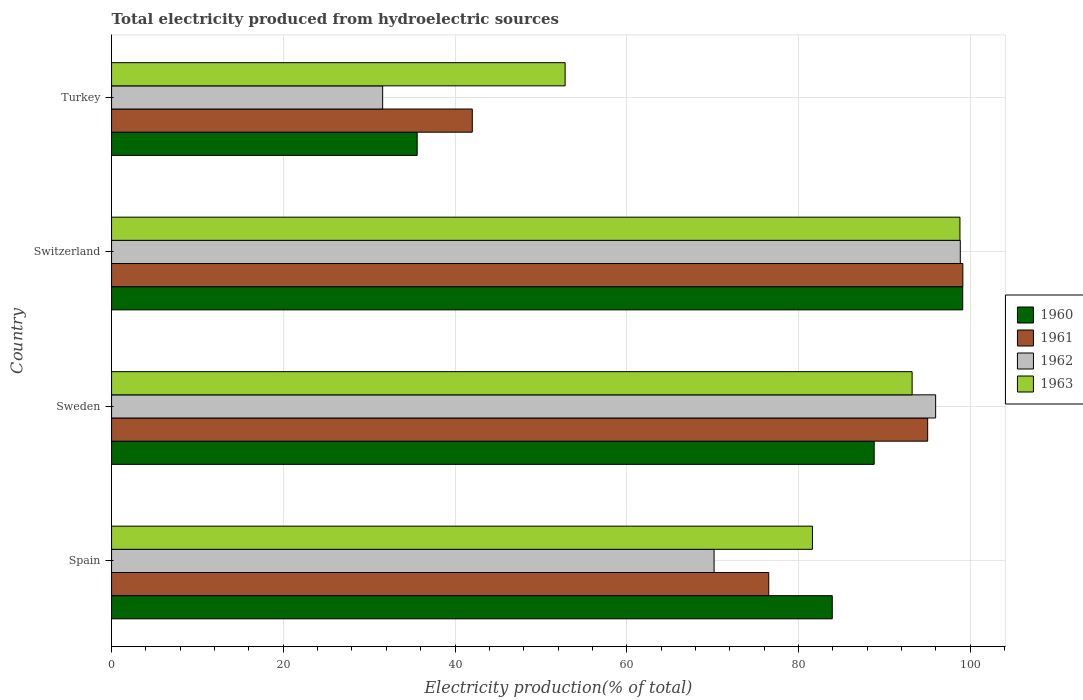How many bars are there on the 4th tick from the top?
Make the answer very short. 4. What is the total electricity produced in 1961 in Spain?
Keep it short and to the point. 76.54. Across all countries, what is the maximum total electricity produced in 1963?
Provide a succinct answer. 98.81. Across all countries, what is the minimum total electricity produced in 1961?
Offer a very short reply. 42.01. In which country was the total electricity produced in 1963 maximum?
Provide a succinct answer. Switzerland. In which country was the total electricity produced in 1961 minimum?
Offer a terse response. Turkey. What is the total total electricity produced in 1962 in the graph?
Give a very brief answer. 296.57. What is the difference between the total electricity produced in 1961 in Spain and that in Switzerland?
Provide a succinct answer. -22.61. What is the difference between the total electricity produced in 1960 in Switzerland and the total electricity produced in 1963 in Turkey?
Keep it short and to the point. 46.31. What is the average total electricity produced in 1960 per country?
Your response must be concise. 76.87. What is the difference between the total electricity produced in 1960 and total electricity produced in 1961 in Switzerland?
Keep it short and to the point. -0.02. In how many countries, is the total electricity produced in 1962 greater than 72 %?
Your response must be concise. 2. What is the ratio of the total electricity produced in 1963 in Spain to that in Switzerland?
Offer a very short reply. 0.83. What is the difference between the highest and the second highest total electricity produced in 1960?
Make the answer very short. 10.31. What is the difference between the highest and the lowest total electricity produced in 1960?
Make the answer very short. 63.54. Is the sum of the total electricity produced in 1961 in Spain and Switzerland greater than the maximum total electricity produced in 1962 across all countries?
Your answer should be very brief. Yes. What does the 1st bar from the top in Spain represents?
Give a very brief answer. 1963. What does the 2nd bar from the bottom in Switzerland represents?
Provide a succinct answer. 1961. Is it the case that in every country, the sum of the total electricity produced in 1962 and total electricity produced in 1961 is greater than the total electricity produced in 1963?
Ensure brevity in your answer.  Yes. Are all the bars in the graph horizontal?
Your response must be concise. Yes. How many countries are there in the graph?
Your response must be concise. 4. Are the values on the major ticks of X-axis written in scientific E-notation?
Your answer should be compact. No. Does the graph contain grids?
Offer a terse response. Yes. Where does the legend appear in the graph?
Offer a terse response. Center right. What is the title of the graph?
Offer a very short reply. Total electricity produced from hydroelectric sources. What is the label or title of the Y-axis?
Make the answer very short. Country. What is the Electricity production(% of total) of 1960 in Spain?
Provide a succinct answer. 83.94. What is the Electricity production(% of total) of 1961 in Spain?
Provide a succinct answer. 76.54. What is the Electricity production(% of total) of 1962 in Spain?
Keep it short and to the point. 70.17. What is the Electricity production(% of total) of 1963 in Spain?
Offer a terse response. 81.63. What is the Electricity production(% of total) in 1960 in Sweden?
Offer a terse response. 88.82. What is the Electricity production(% of total) in 1961 in Sweden?
Make the answer very short. 95.05. What is the Electricity production(% of total) of 1962 in Sweden?
Provide a succinct answer. 95.98. What is the Electricity production(% of total) in 1963 in Sweden?
Offer a very short reply. 93.24. What is the Electricity production(% of total) in 1960 in Switzerland?
Your answer should be very brief. 99.13. What is the Electricity production(% of total) in 1961 in Switzerland?
Give a very brief answer. 99.15. What is the Electricity production(% of total) of 1962 in Switzerland?
Make the answer very short. 98.85. What is the Electricity production(% of total) of 1963 in Switzerland?
Give a very brief answer. 98.81. What is the Electricity production(% of total) in 1960 in Turkey?
Make the answer very short. 35.6. What is the Electricity production(% of total) in 1961 in Turkey?
Make the answer very short. 42.01. What is the Electricity production(% of total) in 1962 in Turkey?
Your answer should be very brief. 31.57. What is the Electricity production(% of total) in 1963 in Turkey?
Provide a short and direct response. 52.82. Across all countries, what is the maximum Electricity production(% of total) in 1960?
Offer a very short reply. 99.13. Across all countries, what is the maximum Electricity production(% of total) in 1961?
Give a very brief answer. 99.15. Across all countries, what is the maximum Electricity production(% of total) of 1962?
Give a very brief answer. 98.85. Across all countries, what is the maximum Electricity production(% of total) of 1963?
Ensure brevity in your answer.  98.81. Across all countries, what is the minimum Electricity production(% of total) in 1960?
Provide a succinct answer. 35.6. Across all countries, what is the minimum Electricity production(% of total) of 1961?
Provide a short and direct response. 42.01. Across all countries, what is the minimum Electricity production(% of total) of 1962?
Offer a terse response. 31.57. Across all countries, what is the minimum Electricity production(% of total) in 1963?
Your answer should be compact. 52.82. What is the total Electricity production(% of total) of 1960 in the graph?
Provide a succinct answer. 307.48. What is the total Electricity production(% of total) in 1961 in the graph?
Your answer should be very brief. 312.75. What is the total Electricity production(% of total) of 1962 in the graph?
Offer a terse response. 296.57. What is the total Electricity production(% of total) in 1963 in the graph?
Offer a very short reply. 326.5. What is the difference between the Electricity production(% of total) of 1960 in Spain and that in Sweden?
Your answer should be compact. -4.88. What is the difference between the Electricity production(% of total) of 1961 in Spain and that in Sweden?
Your answer should be compact. -18.51. What is the difference between the Electricity production(% of total) of 1962 in Spain and that in Sweden?
Make the answer very short. -25.8. What is the difference between the Electricity production(% of total) of 1963 in Spain and that in Sweden?
Provide a succinct answer. -11.61. What is the difference between the Electricity production(% of total) of 1960 in Spain and that in Switzerland?
Provide a succinct answer. -15.19. What is the difference between the Electricity production(% of total) of 1961 in Spain and that in Switzerland?
Your answer should be very brief. -22.61. What is the difference between the Electricity production(% of total) in 1962 in Spain and that in Switzerland?
Provide a succinct answer. -28.67. What is the difference between the Electricity production(% of total) of 1963 in Spain and that in Switzerland?
Offer a very short reply. -17.18. What is the difference between the Electricity production(% of total) of 1960 in Spain and that in Turkey?
Your answer should be compact. 48.34. What is the difference between the Electricity production(% of total) of 1961 in Spain and that in Turkey?
Provide a succinct answer. 34.53. What is the difference between the Electricity production(% of total) in 1962 in Spain and that in Turkey?
Your answer should be compact. 38.6. What is the difference between the Electricity production(% of total) in 1963 in Spain and that in Turkey?
Your response must be concise. 28.8. What is the difference between the Electricity production(% of total) in 1960 in Sweden and that in Switzerland?
Keep it short and to the point. -10.31. What is the difference between the Electricity production(% of total) in 1961 in Sweden and that in Switzerland?
Your answer should be compact. -4.1. What is the difference between the Electricity production(% of total) of 1962 in Sweden and that in Switzerland?
Your response must be concise. -2.87. What is the difference between the Electricity production(% of total) in 1963 in Sweden and that in Switzerland?
Offer a terse response. -5.57. What is the difference between the Electricity production(% of total) of 1960 in Sweden and that in Turkey?
Make the answer very short. 53.22. What is the difference between the Electricity production(% of total) in 1961 in Sweden and that in Turkey?
Your answer should be compact. 53.04. What is the difference between the Electricity production(% of total) in 1962 in Sweden and that in Turkey?
Ensure brevity in your answer.  64.4. What is the difference between the Electricity production(% of total) in 1963 in Sweden and that in Turkey?
Your response must be concise. 40.41. What is the difference between the Electricity production(% of total) in 1960 in Switzerland and that in Turkey?
Your answer should be very brief. 63.54. What is the difference between the Electricity production(% of total) in 1961 in Switzerland and that in Turkey?
Keep it short and to the point. 57.13. What is the difference between the Electricity production(% of total) in 1962 in Switzerland and that in Turkey?
Your answer should be very brief. 67.27. What is the difference between the Electricity production(% of total) of 1963 in Switzerland and that in Turkey?
Your answer should be compact. 45.98. What is the difference between the Electricity production(% of total) in 1960 in Spain and the Electricity production(% of total) in 1961 in Sweden?
Offer a very short reply. -11.11. What is the difference between the Electricity production(% of total) in 1960 in Spain and the Electricity production(% of total) in 1962 in Sweden?
Provide a succinct answer. -12.04. What is the difference between the Electricity production(% of total) in 1960 in Spain and the Electricity production(% of total) in 1963 in Sweden?
Offer a terse response. -9.3. What is the difference between the Electricity production(% of total) of 1961 in Spain and the Electricity production(% of total) of 1962 in Sweden?
Offer a terse response. -19.44. What is the difference between the Electricity production(% of total) in 1961 in Spain and the Electricity production(% of total) in 1963 in Sweden?
Offer a very short reply. -16.7. What is the difference between the Electricity production(% of total) of 1962 in Spain and the Electricity production(% of total) of 1963 in Sweden?
Offer a very short reply. -23.06. What is the difference between the Electricity production(% of total) in 1960 in Spain and the Electricity production(% of total) in 1961 in Switzerland?
Your response must be concise. -15.21. What is the difference between the Electricity production(% of total) of 1960 in Spain and the Electricity production(% of total) of 1962 in Switzerland?
Provide a short and direct response. -14.91. What is the difference between the Electricity production(% of total) in 1960 in Spain and the Electricity production(% of total) in 1963 in Switzerland?
Give a very brief answer. -14.87. What is the difference between the Electricity production(% of total) of 1961 in Spain and the Electricity production(% of total) of 1962 in Switzerland?
Offer a terse response. -22.31. What is the difference between the Electricity production(% of total) of 1961 in Spain and the Electricity production(% of total) of 1963 in Switzerland?
Your response must be concise. -22.27. What is the difference between the Electricity production(% of total) of 1962 in Spain and the Electricity production(% of total) of 1963 in Switzerland?
Your answer should be very brief. -28.63. What is the difference between the Electricity production(% of total) in 1960 in Spain and the Electricity production(% of total) in 1961 in Turkey?
Provide a short and direct response. 41.92. What is the difference between the Electricity production(% of total) of 1960 in Spain and the Electricity production(% of total) of 1962 in Turkey?
Offer a terse response. 52.36. What is the difference between the Electricity production(% of total) of 1960 in Spain and the Electricity production(% of total) of 1963 in Turkey?
Ensure brevity in your answer.  31.11. What is the difference between the Electricity production(% of total) of 1961 in Spain and the Electricity production(% of total) of 1962 in Turkey?
Offer a very short reply. 44.97. What is the difference between the Electricity production(% of total) in 1961 in Spain and the Electricity production(% of total) in 1963 in Turkey?
Make the answer very short. 23.72. What is the difference between the Electricity production(% of total) in 1962 in Spain and the Electricity production(% of total) in 1963 in Turkey?
Your response must be concise. 17.35. What is the difference between the Electricity production(% of total) in 1960 in Sweden and the Electricity production(% of total) in 1961 in Switzerland?
Ensure brevity in your answer.  -10.33. What is the difference between the Electricity production(% of total) in 1960 in Sweden and the Electricity production(% of total) in 1962 in Switzerland?
Your answer should be compact. -10.03. What is the difference between the Electricity production(% of total) of 1960 in Sweden and the Electricity production(% of total) of 1963 in Switzerland?
Your answer should be very brief. -9.99. What is the difference between the Electricity production(% of total) in 1961 in Sweden and the Electricity production(% of total) in 1962 in Switzerland?
Provide a short and direct response. -3.8. What is the difference between the Electricity production(% of total) of 1961 in Sweden and the Electricity production(% of total) of 1963 in Switzerland?
Make the answer very short. -3.76. What is the difference between the Electricity production(% of total) of 1962 in Sweden and the Electricity production(% of total) of 1963 in Switzerland?
Provide a succinct answer. -2.83. What is the difference between the Electricity production(% of total) of 1960 in Sweden and the Electricity production(% of total) of 1961 in Turkey?
Your response must be concise. 46.81. What is the difference between the Electricity production(% of total) in 1960 in Sweden and the Electricity production(% of total) in 1962 in Turkey?
Make the answer very short. 57.25. What is the difference between the Electricity production(% of total) in 1960 in Sweden and the Electricity production(% of total) in 1963 in Turkey?
Ensure brevity in your answer.  36. What is the difference between the Electricity production(% of total) in 1961 in Sweden and the Electricity production(% of total) in 1962 in Turkey?
Your response must be concise. 63.48. What is the difference between the Electricity production(% of total) in 1961 in Sweden and the Electricity production(% of total) in 1963 in Turkey?
Ensure brevity in your answer.  42.22. What is the difference between the Electricity production(% of total) in 1962 in Sweden and the Electricity production(% of total) in 1963 in Turkey?
Your response must be concise. 43.15. What is the difference between the Electricity production(% of total) in 1960 in Switzerland and the Electricity production(% of total) in 1961 in Turkey?
Ensure brevity in your answer.  57.12. What is the difference between the Electricity production(% of total) of 1960 in Switzerland and the Electricity production(% of total) of 1962 in Turkey?
Provide a short and direct response. 67.56. What is the difference between the Electricity production(% of total) of 1960 in Switzerland and the Electricity production(% of total) of 1963 in Turkey?
Ensure brevity in your answer.  46.31. What is the difference between the Electricity production(% of total) of 1961 in Switzerland and the Electricity production(% of total) of 1962 in Turkey?
Make the answer very short. 67.57. What is the difference between the Electricity production(% of total) of 1961 in Switzerland and the Electricity production(% of total) of 1963 in Turkey?
Keep it short and to the point. 46.32. What is the difference between the Electricity production(% of total) in 1962 in Switzerland and the Electricity production(% of total) in 1963 in Turkey?
Your answer should be very brief. 46.02. What is the average Electricity production(% of total) of 1960 per country?
Your answer should be compact. 76.87. What is the average Electricity production(% of total) in 1961 per country?
Your response must be concise. 78.19. What is the average Electricity production(% of total) in 1962 per country?
Give a very brief answer. 74.14. What is the average Electricity production(% of total) of 1963 per country?
Keep it short and to the point. 81.62. What is the difference between the Electricity production(% of total) in 1960 and Electricity production(% of total) in 1961 in Spain?
Offer a very short reply. 7.4. What is the difference between the Electricity production(% of total) in 1960 and Electricity production(% of total) in 1962 in Spain?
Give a very brief answer. 13.76. What is the difference between the Electricity production(% of total) of 1960 and Electricity production(% of total) of 1963 in Spain?
Provide a succinct answer. 2.31. What is the difference between the Electricity production(% of total) of 1961 and Electricity production(% of total) of 1962 in Spain?
Your answer should be very brief. 6.37. What is the difference between the Electricity production(% of total) of 1961 and Electricity production(% of total) of 1963 in Spain?
Provide a short and direct response. -5.09. What is the difference between the Electricity production(% of total) of 1962 and Electricity production(% of total) of 1963 in Spain?
Your answer should be compact. -11.45. What is the difference between the Electricity production(% of total) in 1960 and Electricity production(% of total) in 1961 in Sweden?
Ensure brevity in your answer.  -6.23. What is the difference between the Electricity production(% of total) of 1960 and Electricity production(% of total) of 1962 in Sweden?
Make the answer very short. -7.16. What is the difference between the Electricity production(% of total) in 1960 and Electricity production(% of total) in 1963 in Sweden?
Provide a short and direct response. -4.42. What is the difference between the Electricity production(% of total) in 1961 and Electricity production(% of total) in 1962 in Sweden?
Ensure brevity in your answer.  -0.93. What is the difference between the Electricity production(% of total) in 1961 and Electricity production(% of total) in 1963 in Sweden?
Your response must be concise. 1.81. What is the difference between the Electricity production(% of total) in 1962 and Electricity production(% of total) in 1963 in Sweden?
Make the answer very short. 2.74. What is the difference between the Electricity production(% of total) of 1960 and Electricity production(% of total) of 1961 in Switzerland?
Make the answer very short. -0.02. What is the difference between the Electricity production(% of total) of 1960 and Electricity production(% of total) of 1962 in Switzerland?
Make the answer very short. 0.28. What is the difference between the Electricity production(% of total) in 1960 and Electricity production(% of total) in 1963 in Switzerland?
Provide a succinct answer. 0.32. What is the difference between the Electricity production(% of total) of 1961 and Electricity production(% of total) of 1962 in Switzerland?
Provide a succinct answer. 0.3. What is the difference between the Electricity production(% of total) in 1961 and Electricity production(% of total) in 1963 in Switzerland?
Offer a terse response. 0.34. What is the difference between the Electricity production(% of total) in 1962 and Electricity production(% of total) in 1963 in Switzerland?
Offer a terse response. 0.04. What is the difference between the Electricity production(% of total) of 1960 and Electricity production(% of total) of 1961 in Turkey?
Offer a very short reply. -6.42. What is the difference between the Electricity production(% of total) of 1960 and Electricity production(% of total) of 1962 in Turkey?
Make the answer very short. 4.02. What is the difference between the Electricity production(% of total) of 1960 and Electricity production(% of total) of 1963 in Turkey?
Make the answer very short. -17.23. What is the difference between the Electricity production(% of total) of 1961 and Electricity production(% of total) of 1962 in Turkey?
Ensure brevity in your answer.  10.44. What is the difference between the Electricity production(% of total) of 1961 and Electricity production(% of total) of 1963 in Turkey?
Offer a terse response. -10.81. What is the difference between the Electricity production(% of total) of 1962 and Electricity production(% of total) of 1963 in Turkey?
Ensure brevity in your answer.  -21.25. What is the ratio of the Electricity production(% of total) of 1960 in Spain to that in Sweden?
Give a very brief answer. 0.94. What is the ratio of the Electricity production(% of total) in 1961 in Spain to that in Sweden?
Give a very brief answer. 0.81. What is the ratio of the Electricity production(% of total) in 1962 in Spain to that in Sweden?
Keep it short and to the point. 0.73. What is the ratio of the Electricity production(% of total) of 1963 in Spain to that in Sweden?
Provide a succinct answer. 0.88. What is the ratio of the Electricity production(% of total) of 1960 in Spain to that in Switzerland?
Provide a succinct answer. 0.85. What is the ratio of the Electricity production(% of total) of 1961 in Spain to that in Switzerland?
Your answer should be very brief. 0.77. What is the ratio of the Electricity production(% of total) in 1962 in Spain to that in Switzerland?
Keep it short and to the point. 0.71. What is the ratio of the Electricity production(% of total) of 1963 in Spain to that in Switzerland?
Your response must be concise. 0.83. What is the ratio of the Electricity production(% of total) in 1960 in Spain to that in Turkey?
Keep it short and to the point. 2.36. What is the ratio of the Electricity production(% of total) in 1961 in Spain to that in Turkey?
Provide a succinct answer. 1.82. What is the ratio of the Electricity production(% of total) of 1962 in Spain to that in Turkey?
Your answer should be compact. 2.22. What is the ratio of the Electricity production(% of total) in 1963 in Spain to that in Turkey?
Your response must be concise. 1.55. What is the ratio of the Electricity production(% of total) in 1960 in Sweden to that in Switzerland?
Provide a succinct answer. 0.9. What is the ratio of the Electricity production(% of total) of 1961 in Sweden to that in Switzerland?
Your answer should be very brief. 0.96. What is the ratio of the Electricity production(% of total) of 1962 in Sweden to that in Switzerland?
Offer a very short reply. 0.97. What is the ratio of the Electricity production(% of total) in 1963 in Sweden to that in Switzerland?
Provide a short and direct response. 0.94. What is the ratio of the Electricity production(% of total) in 1960 in Sweden to that in Turkey?
Your response must be concise. 2.5. What is the ratio of the Electricity production(% of total) of 1961 in Sweden to that in Turkey?
Offer a terse response. 2.26. What is the ratio of the Electricity production(% of total) in 1962 in Sweden to that in Turkey?
Provide a short and direct response. 3.04. What is the ratio of the Electricity production(% of total) in 1963 in Sweden to that in Turkey?
Your answer should be very brief. 1.76. What is the ratio of the Electricity production(% of total) of 1960 in Switzerland to that in Turkey?
Keep it short and to the point. 2.79. What is the ratio of the Electricity production(% of total) in 1961 in Switzerland to that in Turkey?
Provide a succinct answer. 2.36. What is the ratio of the Electricity production(% of total) of 1962 in Switzerland to that in Turkey?
Offer a terse response. 3.13. What is the ratio of the Electricity production(% of total) of 1963 in Switzerland to that in Turkey?
Keep it short and to the point. 1.87. What is the difference between the highest and the second highest Electricity production(% of total) in 1960?
Make the answer very short. 10.31. What is the difference between the highest and the second highest Electricity production(% of total) in 1961?
Provide a succinct answer. 4.1. What is the difference between the highest and the second highest Electricity production(% of total) of 1962?
Provide a succinct answer. 2.87. What is the difference between the highest and the second highest Electricity production(% of total) of 1963?
Keep it short and to the point. 5.57. What is the difference between the highest and the lowest Electricity production(% of total) of 1960?
Ensure brevity in your answer.  63.54. What is the difference between the highest and the lowest Electricity production(% of total) of 1961?
Keep it short and to the point. 57.13. What is the difference between the highest and the lowest Electricity production(% of total) of 1962?
Ensure brevity in your answer.  67.27. What is the difference between the highest and the lowest Electricity production(% of total) in 1963?
Your response must be concise. 45.98. 